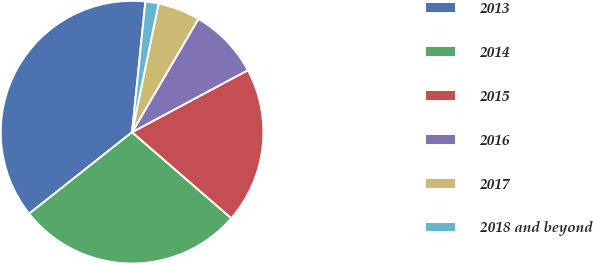Convert chart. <chart><loc_0><loc_0><loc_500><loc_500><pie_chart><fcel>2013<fcel>2014<fcel>2015<fcel>2016<fcel>2017<fcel>2018 and beyond<nl><fcel>37.28%<fcel>27.97%<fcel>19.2%<fcel>8.75%<fcel>5.19%<fcel>1.62%<nl></chart> 